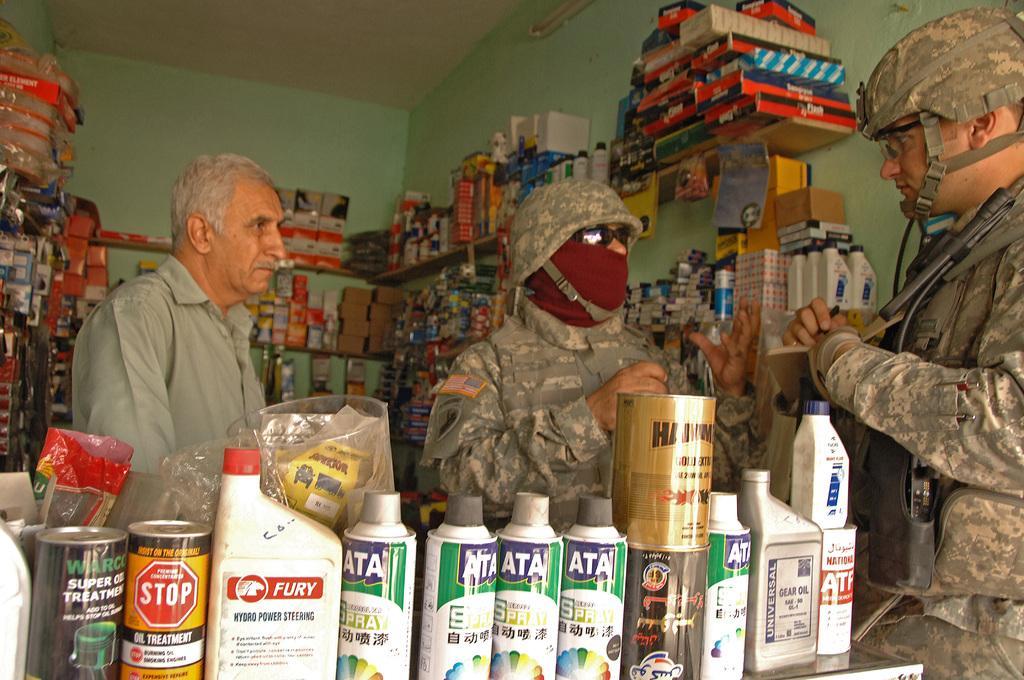How would you summarize this image in a sentence or two? At the bottom of the image there are some bottles and tins. In the middle of the image three persons are standing and watching. Behind them there are some products. At the top of the image there is wall. 